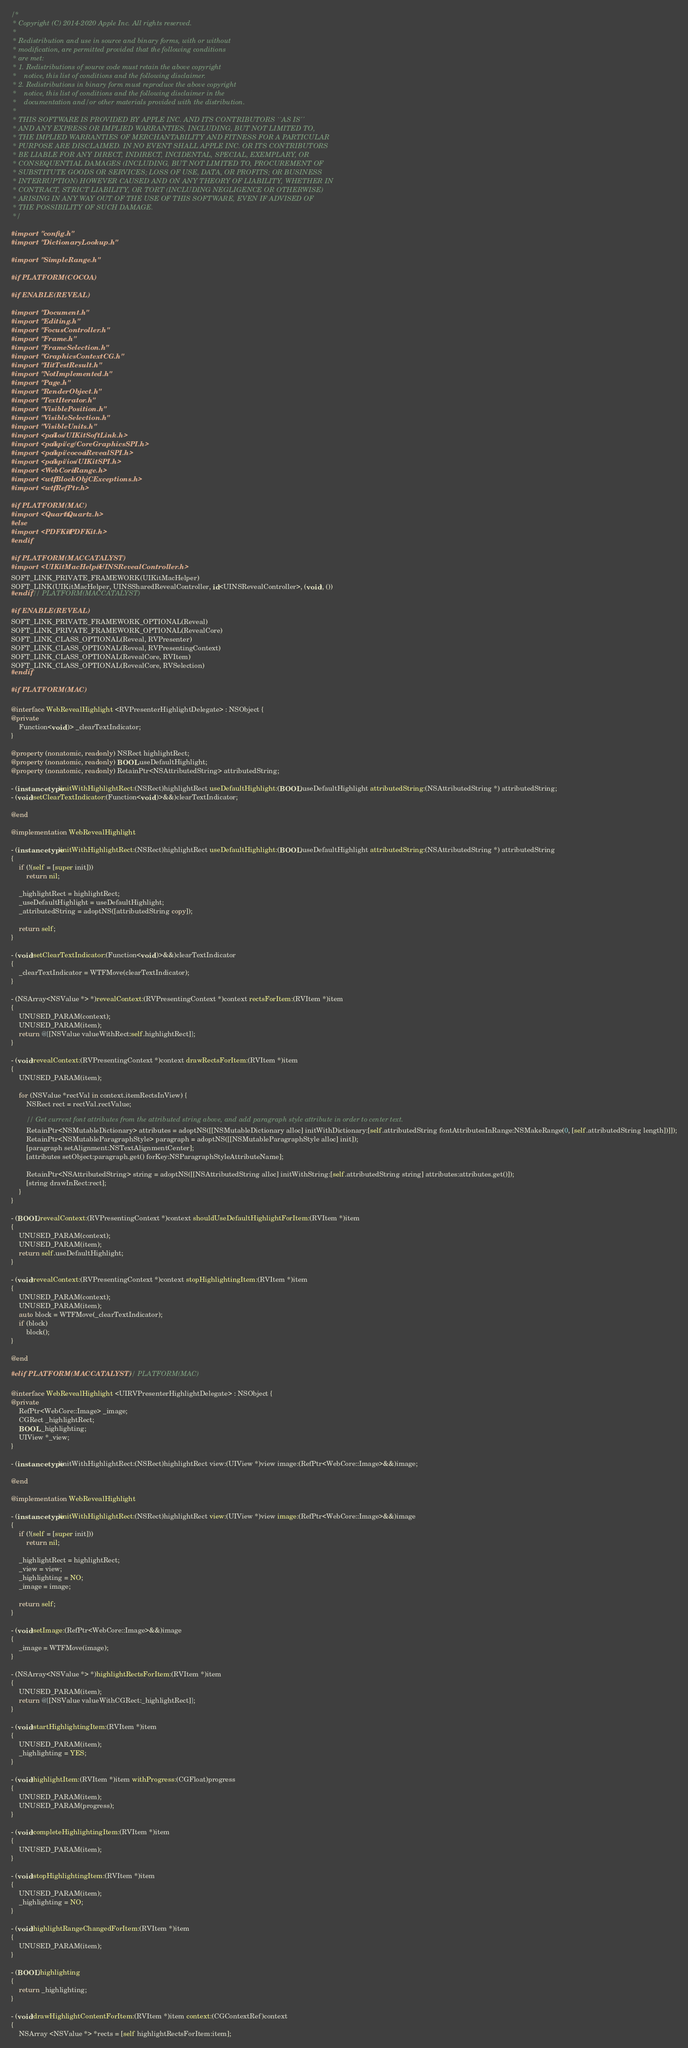Convert code to text. <code><loc_0><loc_0><loc_500><loc_500><_ObjectiveC_>/*
 * Copyright (C) 2014-2020 Apple Inc. All rights reserved.
 *
 * Redistribution and use in source and binary forms, with or without
 * modification, are permitted provided that the following conditions
 * are met:
 * 1. Redistributions of source code must retain the above copyright
 *    notice, this list of conditions and the following disclaimer.
 * 2. Redistributions in binary form must reproduce the above copyright
 *    notice, this list of conditions and the following disclaimer in the
 *    documentation and/or other materials provided with the distribution.
 *
 * THIS SOFTWARE IS PROVIDED BY APPLE INC. AND ITS CONTRIBUTORS ``AS IS''
 * AND ANY EXPRESS OR IMPLIED WARRANTIES, INCLUDING, BUT NOT LIMITED TO,
 * THE IMPLIED WARRANTIES OF MERCHANTABILITY AND FITNESS FOR A PARTICULAR
 * PURPOSE ARE DISCLAIMED. IN NO EVENT SHALL APPLE INC. OR ITS CONTRIBUTORS
 * BE LIABLE FOR ANY DIRECT, INDIRECT, INCIDENTAL, SPECIAL, EXEMPLARY, OR
 * CONSEQUENTIAL DAMAGES (INCLUDING, BUT NOT LIMITED TO, PROCUREMENT OF
 * SUBSTITUTE GOODS OR SERVICES; LOSS OF USE, DATA, OR PROFITS; OR BUSINESS
 * INTERRUPTION) HOWEVER CAUSED AND ON ANY THEORY OF LIABILITY, WHETHER IN
 * CONTRACT, STRICT LIABILITY, OR TORT (INCLUDING NEGLIGENCE OR OTHERWISE)
 * ARISING IN ANY WAY OUT OF THE USE OF THIS SOFTWARE, EVEN IF ADVISED OF
 * THE POSSIBILITY OF SUCH DAMAGE.
 */

#import "config.h"
#import "DictionaryLookup.h"

#import "SimpleRange.h"

#if PLATFORM(COCOA)

#if ENABLE(REVEAL)

#import "Document.h"
#import "Editing.h"
#import "FocusController.h"
#import "Frame.h"
#import "FrameSelection.h"
#import "GraphicsContextCG.h"
#import "HitTestResult.h"
#import "NotImplemented.h"
#import "Page.h"
#import "RenderObject.h"
#import "TextIterator.h"
#import "VisiblePosition.h"
#import "VisibleSelection.h"
#import "VisibleUnits.h"
#import <pal/ios/UIKitSoftLink.h>
#import <pal/spi/cg/CoreGraphicsSPI.h>
#import <pal/spi/cocoa/RevealSPI.h>
#import <pal/spi/ios/UIKitSPI.h>
#import <WebCore/Range.h>
#import <wtf/BlockObjCExceptions.h>
#import <wtf/RefPtr.h>

#if PLATFORM(MAC)
#import <Quartz/Quartz.h>
#else
#import <PDFKit/PDFKit.h>
#endif

#if PLATFORM(MACCATALYST)
#import <UIKitMacHelper/UINSRevealController.h>
SOFT_LINK_PRIVATE_FRAMEWORK(UIKitMacHelper)
SOFT_LINK(UIKitMacHelper, UINSSharedRevealController, id<UINSRevealController>, (void), ())
#endif // PLATFORM(MACCATALYST)

#if ENABLE(REVEAL)
SOFT_LINK_PRIVATE_FRAMEWORK_OPTIONAL(Reveal)
SOFT_LINK_PRIVATE_FRAMEWORK_OPTIONAL(RevealCore)
SOFT_LINK_CLASS_OPTIONAL(Reveal, RVPresenter)
SOFT_LINK_CLASS_OPTIONAL(Reveal, RVPresentingContext)
SOFT_LINK_CLASS_OPTIONAL(RevealCore, RVItem)
SOFT_LINK_CLASS_OPTIONAL(RevealCore, RVSelection)
#endif

#if PLATFORM(MAC)

@interface WebRevealHighlight <RVPresenterHighlightDelegate> : NSObject {
@private
    Function<void()> _clearTextIndicator;
}

@property (nonatomic, readonly) NSRect highlightRect;
@property (nonatomic, readonly) BOOL useDefaultHighlight;
@property (nonatomic, readonly) RetainPtr<NSAttributedString> attributedString;

- (instancetype)initWithHighlightRect:(NSRect)highlightRect useDefaultHighlight:(BOOL)useDefaultHighlight attributedString:(NSAttributedString *) attributedString;
- (void)setClearTextIndicator:(Function<void()>&&)clearTextIndicator;

@end

@implementation WebRevealHighlight

- (instancetype)initWithHighlightRect:(NSRect)highlightRect useDefaultHighlight:(BOOL)useDefaultHighlight attributedString:(NSAttributedString *) attributedString
{
    if (!(self = [super init]))
        return nil;
    
    _highlightRect = highlightRect;
    _useDefaultHighlight = useDefaultHighlight;
    _attributedString = adoptNS([attributedString copy]);
    
    return self;
}

- (void)setClearTextIndicator:(Function<void()>&&)clearTextIndicator
{
    _clearTextIndicator = WTFMove(clearTextIndicator);
}

- (NSArray<NSValue *> *)revealContext:(RVPresentingContext *)context rectsForItem:(RVItem *)item
{
    UNUSED_PARAM(context);
    UNUSED_PARAM(item);
    return @[[NSValue valueWithRect:self.highlightRect]];
}

- (void)revealContext:(RVPresentingContext *)context drawRectsForItem:(RVItem *)item
{
    UNUSED_PARAM(item);
    
    for (NSValue *rectVal in context.itemRectsInView) {
        NSRect rect = rectVal.rectValue;

        // Get current font attributes from the attributed string above, and add paragraph style attribute in order to center text.
        RetainPtr<NSMutableDictionary> attributes = adoptNS([[NSMutableDictionary alloc] initWithDictionary:[self.attributedString fontAttributesInRange:NSMakeRange(0, [self.attributedString length])]]);
        RetainPtr<NSMutableParagraphStyle> paragraph = adoptNS([[NSMutableParagraphStyle alloc] init]);
        [paragraph setAlignment:NSTextAlignmentCenter];
        [attributes setObject:paragraph.get() forKey:NSParagraphStyleAttributeName];
    
        RetainPtr<NSAttributedString> string = adoptNS([[NSAttributedString alloc] initWithString:[self.attributedString string] attributes:attributes.get()]);
        [string drawInRect:rect];
    }
}

- (BOOL)revealContext:(RVPresentingContext *)context shouldUseDefaultHighlightForItem:(RVItem *)item
{
    UNUSED_PARAM(context);
    UNUSED_PARAM(item);
    return self.useDefaultHighlight;
}

- (void)revealContext:(RVPresentingContext *)context stopHighlightingItem:(RVItem *)item
{
    UNUSED_PARAM(context);
    UNUSED_PARAM(item);
    auto block = WTFMove(_clearTextIndicator);
    if (block)
        block();
}

@end

#elif PLATFORM(MACCATALYST) // PLATFORM(MAC)

@interface WebRevealHighlight <UIRVPresenterHighlightDelegate> : NSObject {
@private
    RefPtr<WebCore::Image> _image;
    CGRect _highlightRect;
    BOOL _highlighting;
    UIView *_view;
}

- (instancetype)initWithHighlightRect:(NSRect)highlightRect view:(UIView *)view image:(RefPtr<WebCore::Image>&&)image;

@end

@implementation WebRevealHighlight

- (instancetype)initWithHighlightRect:(NSRect)highlightRect view:(UIView *)view image:(RefPtr<WebCore::Image>&&)image
{
    if (!(self = [super init]))
        return nil;
    
    _highlightRect = highlightRect;
    _view = view;
    _highlighting = NO;
    _image = image;
    
    return self;
}

- (void)setImage:(RefPtr<WebCore::Image>&&)image
{
    _image = WTFMove(image);
}

- (NSArray<NSValue *> *)highlightRectsForItem:(RVItem *)item
{
    UNUSED_PARAM(item);
    return @[[NSValue valueWithCGRect:_highlightRect]];
}

- (void)startHighlightingItem:(RVItem *)item
{
    UNUSED_PARAM(item);
    _highlighting = YES;
}

- (void)highlightItem:(RVItem *)item withProgress:(CGFloat)progress
{
    UNUSED_PARAM(item);
    UNUSED_PARAM(progress);
}

- (void)completeHighlightingItem:(RVItem *)item
{
    UNUSED_PARAM(item);
}

- (void)stopHighlightingItem:(RVItem *)item
{
    UNUSED_PARAM(item);
    _highlighting = NO;
}

- (void)highlightRangeChangedForItem:(RVItem *)item
{
    UNUSED_PARAM(item);
}

- (BOOL)highlighting
{
    return _highlighting;
}

- (void)drawHighlightContentForItem:(RVItem *)item context:(CGContextRef)context
{
    NSArray <NSValue *> *rects = [self highlightRectsForItem:item];</code> 